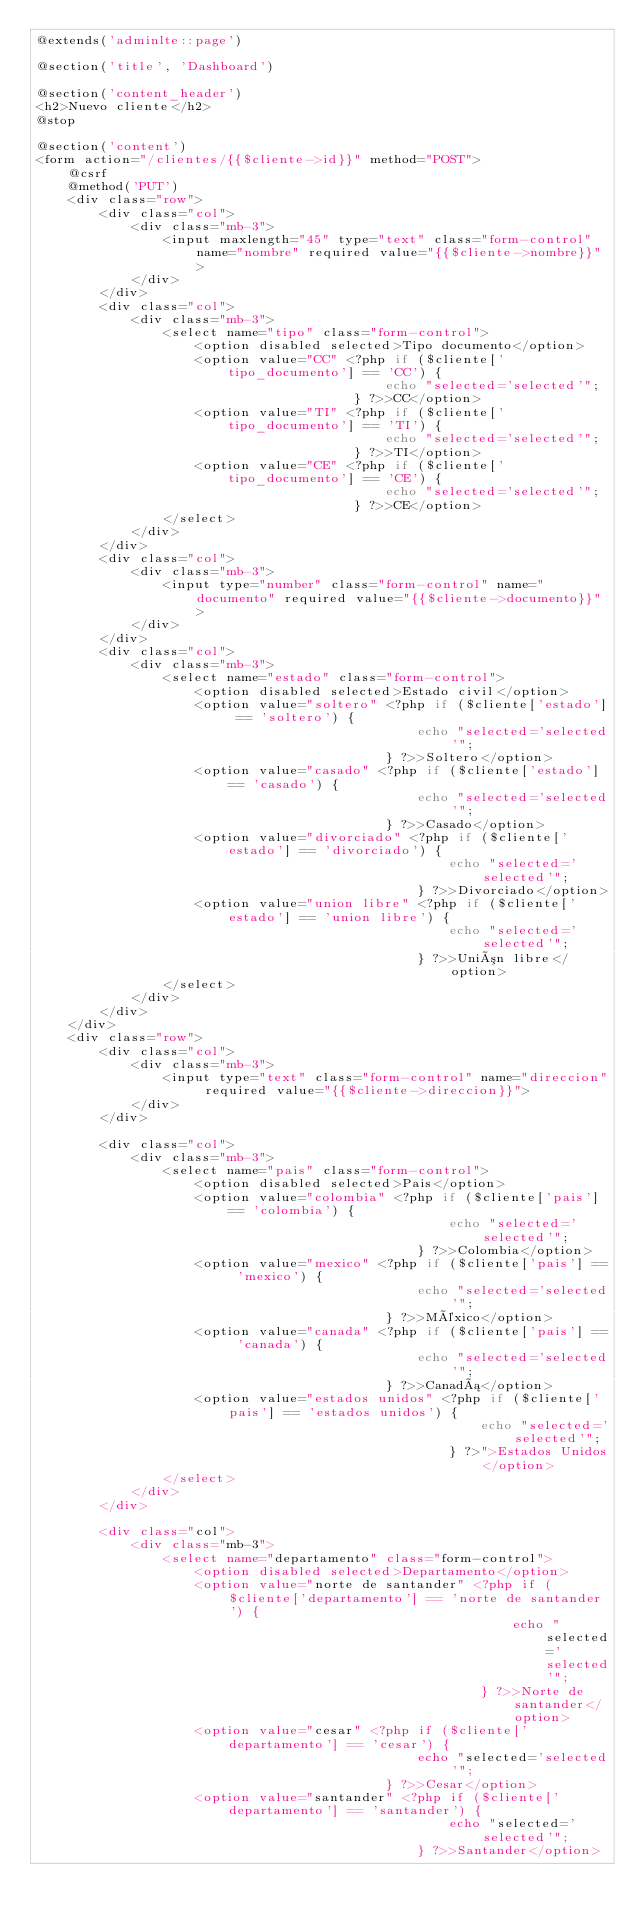Convert code to text. <code><loc_0><loc_0><loc_500><loc_500><_PHP_>@extends('adminlte::page')

@section('title', 'Dashboard')

@section('content_header')
<h2>Nuevo cliente</h2>
@stop

@section('content')
<form action="/clientes/{{$cliente->id}}" method="POST">
    @csrf
    @method('PUT')
    <div class="row">
        <div class="col">
            <div class="mb-3">
                <input maxlength="45" type="text" class="form-control" name="nombre" required value="{{$cliente->nombre}}">
            </div>
        </div>
        <div class="col">
            <div class="mb-3">
                <select name="tipo" class="form-control">
                    <option disabled selected>Tipo documento</option>
                    <option value="CC" <?php if ($cliente['tipo_documento'] == 'CC') {
                                            echo "selected='selected'";
                                        } ?>>CC</option>
                    <option value="TI" <?php if ($cliente['tipo_documento'] == 'TI') {
                                            echo "selected='selected'";
                                        } ?>>TI</option>
                    <option value="CE" <?php if ($cliente['tipo_documento'] == 'CE') {
                                            echo "selected='selected'";
                                        } ?>>CE</option>
                </select>
            </div>
        </div>
        <div class="col">
            <div class="mb-3">
                <input type="number" class="form-control" name="documento" required value="{{$cliente->documento}}">
            </div>
        </div>
        <div class="col">
            <div class="mb-3">
                <select name="estado" class="form-control">
                    <option disabled selected>Estado civil</option>
                    <option value="soltero" <?php if ($cliente['estado'] == 'soltero') {
                                                echo "selected='selected'";
                                            } ?>>Soltero</option>
                    <option value="casado" <?php if ($cliente['estado'] == 'casado') {
                                                echo "selected='selected'";
                                            } ?>>Casado</option>
                    <option value="divorciado" <?php if ($cliente['estado'] == 'divorciado') {
                                                    echo "selected='selected'";
                                                } ?>>Divorciado</option>
                    <option value="union libre" <?php if ($cliente['estado'] == 'union libre') {
                                                    echo "selected='selected'";
                                                } ?>>Unión libre</option>
                </select>
            </div>
        </div>
    </div>
    <div class="row">
        <div class="col">
            <div class="mb-3">
                <input type="text" class="form-control" name="direccion" required value="{{$cliente->direccion}}">
            </div>
        </div>

        <div class="col">
            <div class="mb-3">
                <select name="pais" class="form-control">
                    <option disabled selected>Pais</option>
                    <option value="colombia" <?php if ($cliente['pais'] == 'colombia') {
                                                    echo "selected='selected'";
                                                } ?>>Colombia</option>
                    <option value="mexico" <?php if ($cliente['pais'] == 'mexico') {
                                                echo "selected='selected'";
                                            } ?>>México</option>
                    <option value="canada" <?php if ($cliente['pais'] == 'canada') {
                                                echo "selected='selected'";
                                            } ?>>Canadá</option>
                    <option value="estados unidos" <?php if ($cliente['pais'] == 'estados unidos') {
                                                        echo "selected='selected'";
                                                    } ?>">Estados Unidos</option>
                </select>
            </div>
        </div>

        <div class="col">
            <div class="mb-3">
                <select name="departamento" class="form-control">
                    <option disabled selected>Departamento</option>
                    <option value="norte de santander" <?php if ($cliente['departamento'] == 'norte de santander') {
                                                            echo "selected='selected'";
                                                        } ?>>Norte de santander</option>
                    <option value="cesar" <?php if ($cliente['departamento'] == 'cesar') {
                                                echo "selected='selected'";
                                            } ?>>Cesar</option>
                    <option value="santander" <?php if ($cliente['departamento'] == 'santander') {
                                                    echo "selected='selected'";
                                                } ?>>Santander</option></code> 